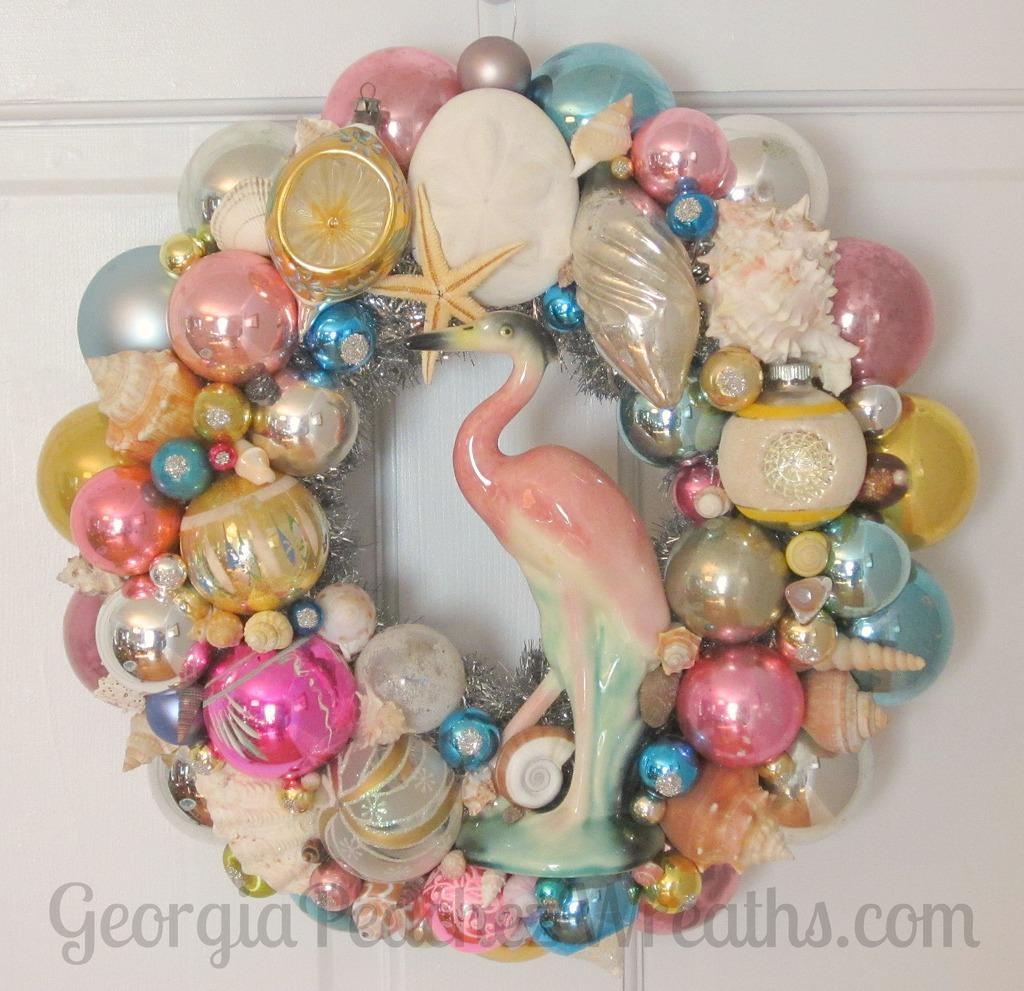What is attached to the white color wall in the image? The provided facts do not specify the objects attached to the wall, so we cannot answer this question definitively. Can you describe the watermark visible in the image? The provided facts do not give any details about the watermark, so we cannot answer this question definitively. What advice does your aunt give about managing friction in the image? There is no mention of an aunt or friction in the image, so we cannot answer this question. 